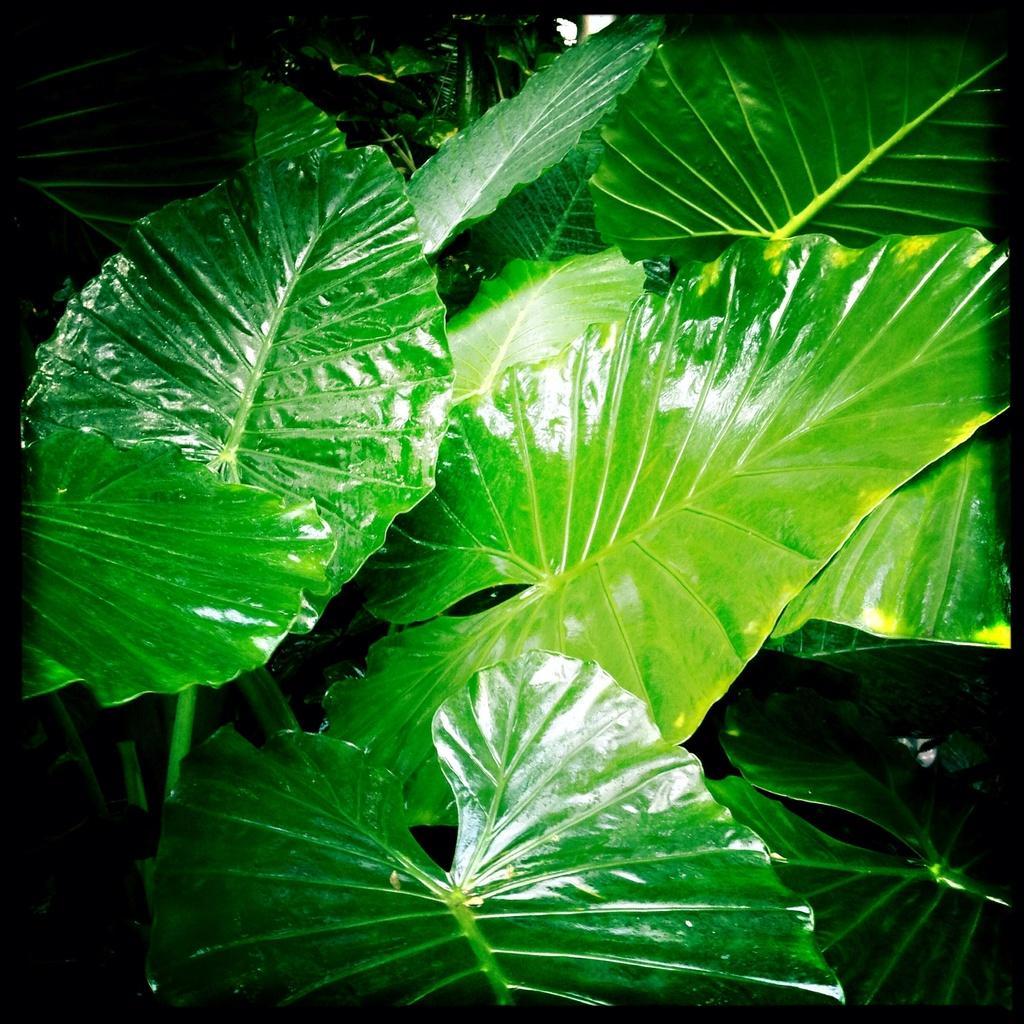Can you describe this image briefly? In this picture there are plants. This picture is an edited picture. 